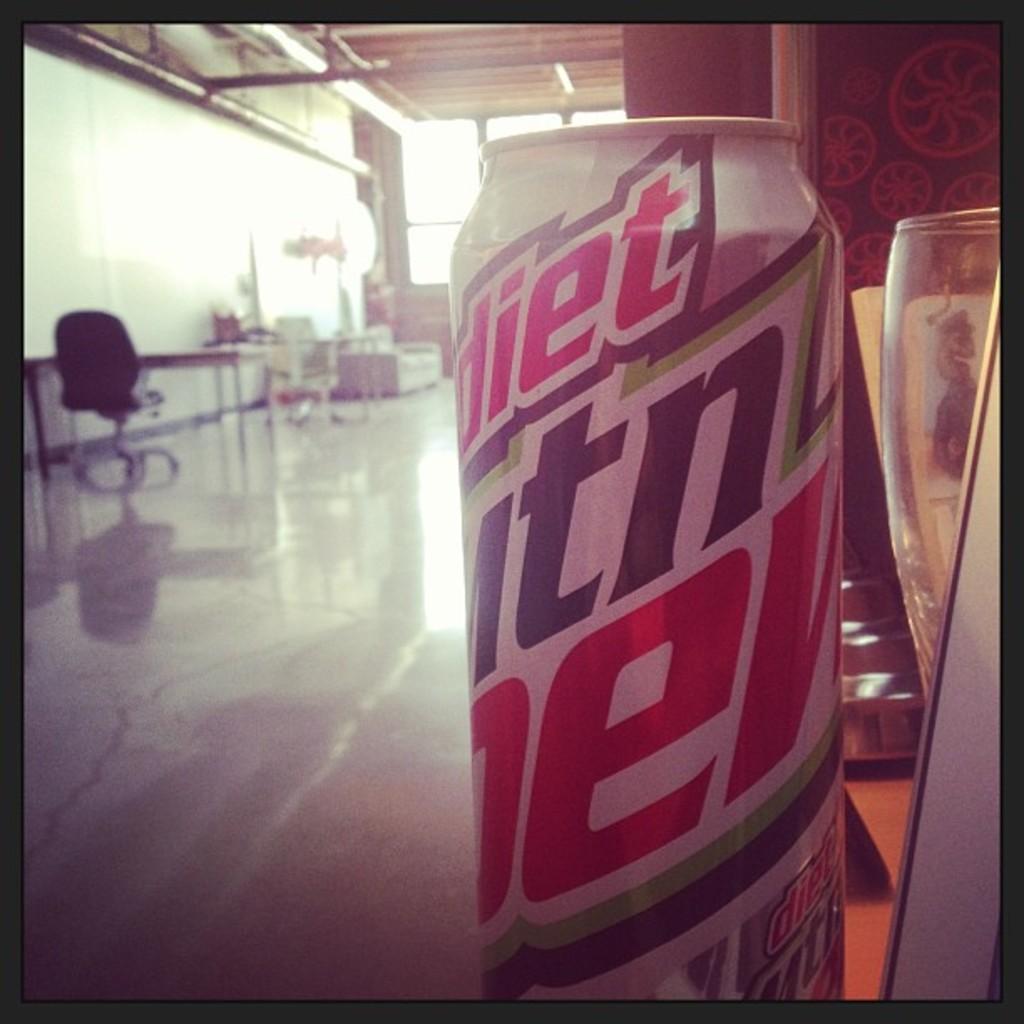What kind of drink is in the can?
Offer a terse response. Diet mtn dew. Is this a diert beverage?
Your response must be concise. Yes. 